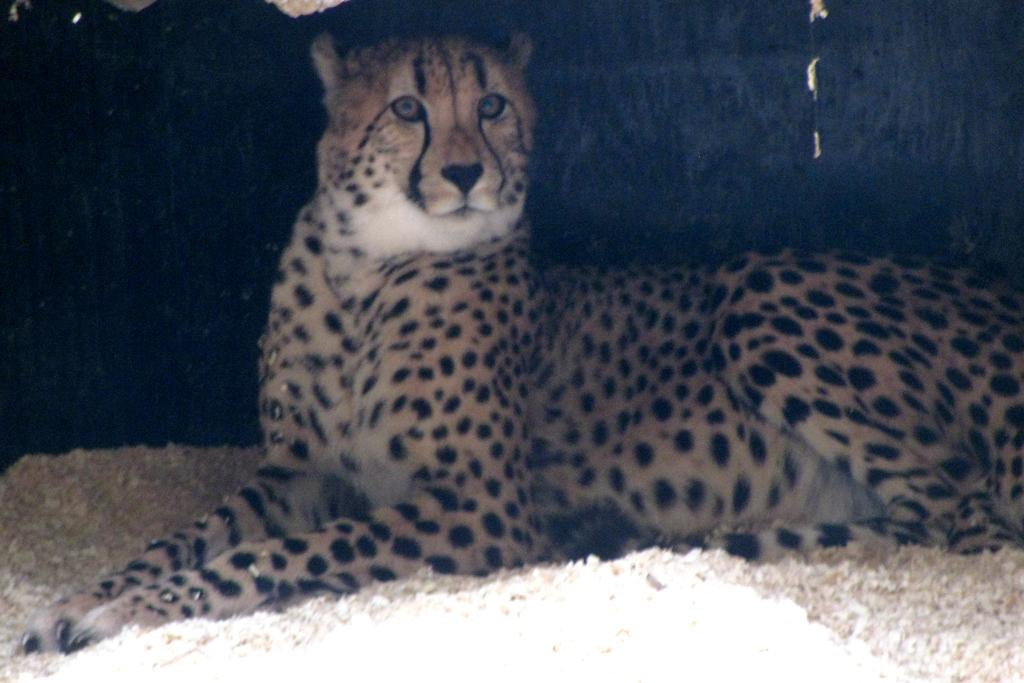What type of animal is in the image? The animal in the image is not specified, but it has brown, white, and black colors. Can you describe the color pattern of the animal? The animal has brown, white, and black colors. What is the background color of the image? The background of the image is black. What type of oatmeal is being served in the scene? There is no oatmeal present in the image, as the facts only mention an animal with specific colors and a black background. 